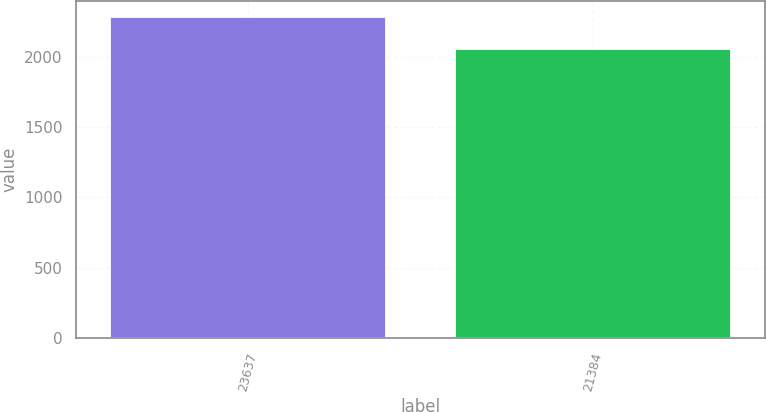Convert chart. <chart><loc_0><loc_0><loc_500><loc_500><bar_chart><fcel>23637<fcel>21384<nl><fcel>2284.5<fcel>2058.5<nl></chart> 